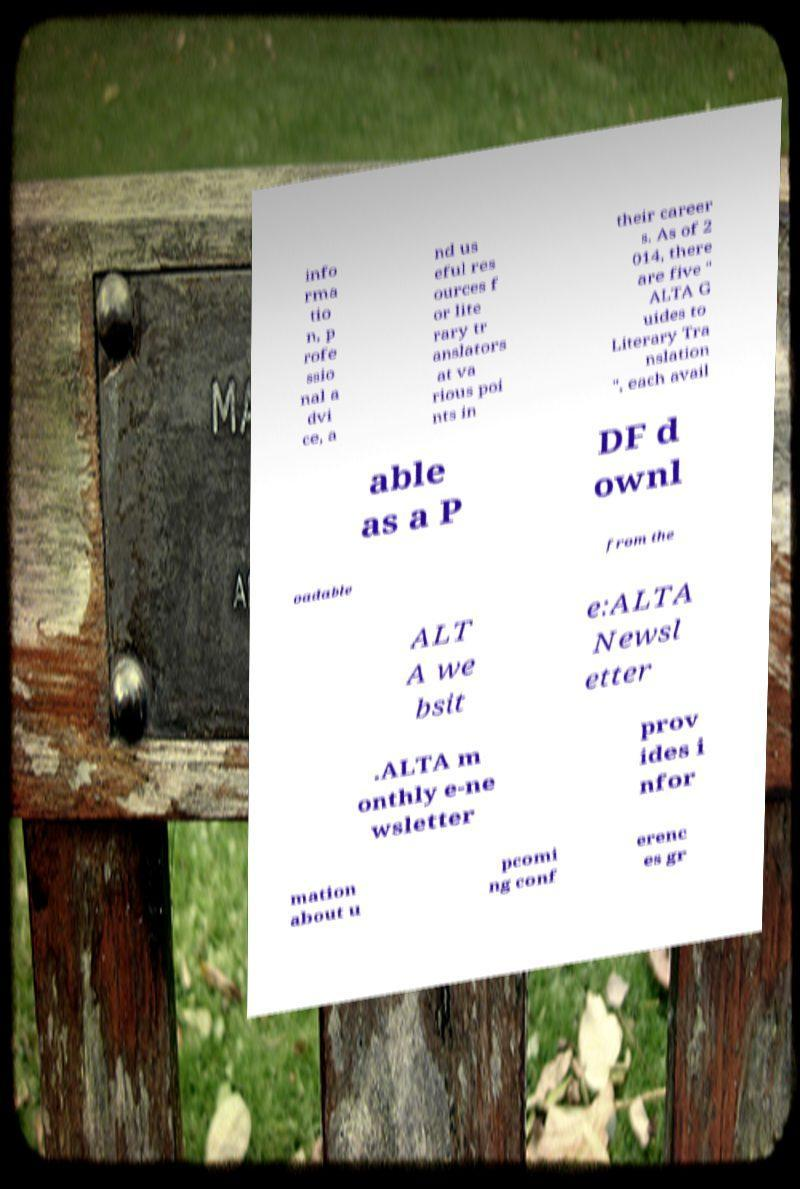I need the written content from this picture converted into text. Can you do that? info rma tio n, p rofe ssio nal a dvi ce, a nd us eful res ources f or lite rary tr anslators at va rious poi nts in their career s. As of 2 014, there are five " ALTA G uides to Literary Tra nslation ", each avail able as a P DF d ownl oadable from the ALT A we bsit e:ALTA Newsl etter .ALTA m onthly e-ne wsletter prov ides i nfor mation about u pcomi ng conf erenc es gr 